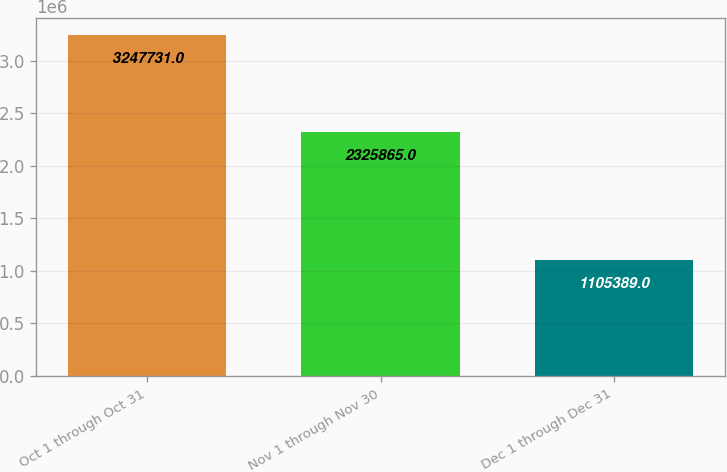Convert chart. <chart><loc_0><loc_0><loc_500><loc_500><bar_chart><fcel>Oct 1 through Oct 31<fcel>Nov 1 through Nov 30<fcel>Dec 1 through Dec 31<nl><fcel>3.24773e+06<fcel>2.32586e+06<fcel>1.10539e+06<nl></chart> 